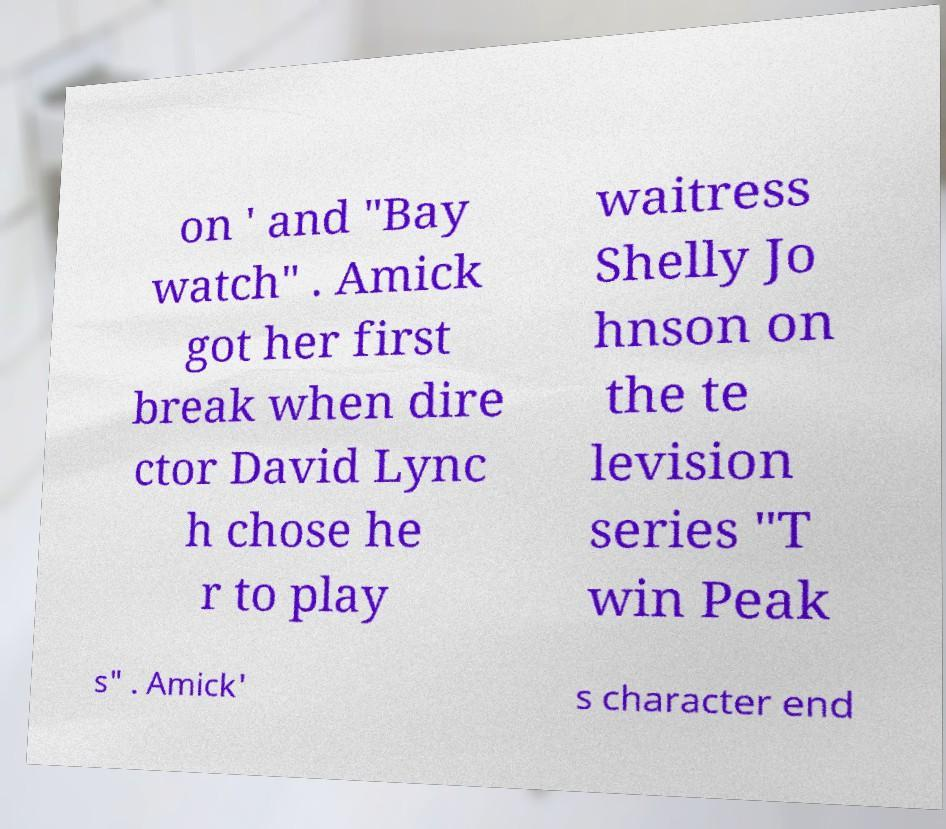There's text embedded in this image that I need extracted. Can you transcribe it verbatim? on ' and "Bay watch" . Amick got her first break when dire ctor David Lync h chose he r to play waitress Shelly Jo hnson on the te levision series "T win Peak s" . Amick' s character end 